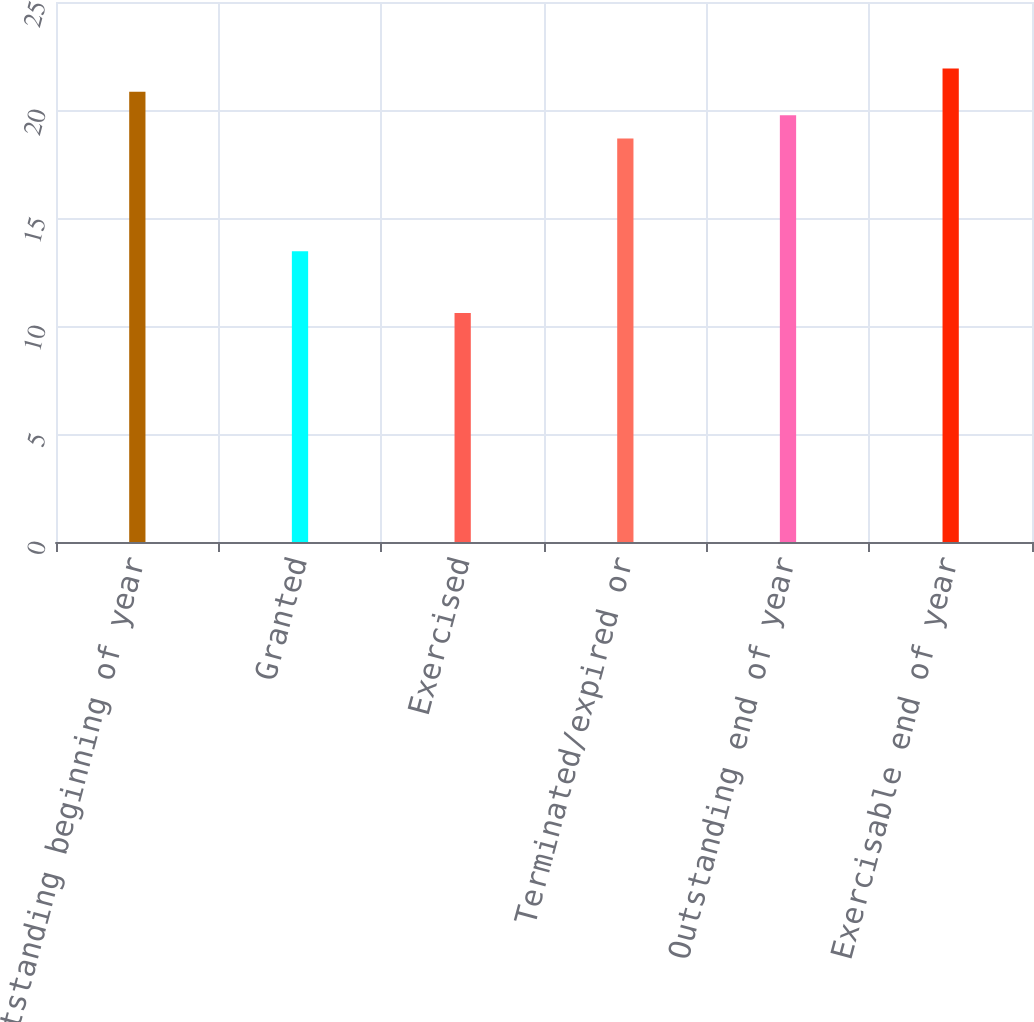Convert chart. <chart><loc_0><loc_0><loc_500><loc_500><bar_chart><fcel>Outstanding beginning of year<fcel>Granted<fcel>Exercised<fcel>Terminated/expired or<fcel>Outstanding end of year<fcel>Exercisable end of year<nl><fcel>20.84<fcel>13.46<fcel>10.6<fcel>18.68<fcel>19.76<fcel>21.92<nl></chart> 